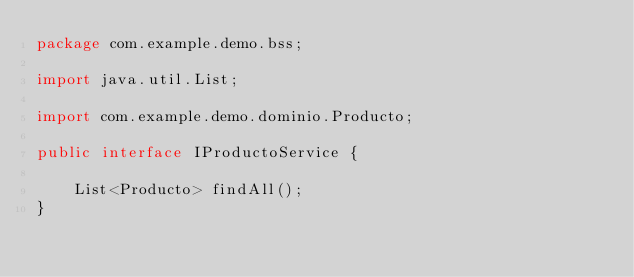Convert code to text. <code><loc_0><loc_0><loc_500><loc_500><_Java_>package com.example.demo.bss;

import java.util.List;

import com.example.demo.dominio.Producto;

public interface IProductoService {
	
	List<Producto> findAll();
}
</code> 